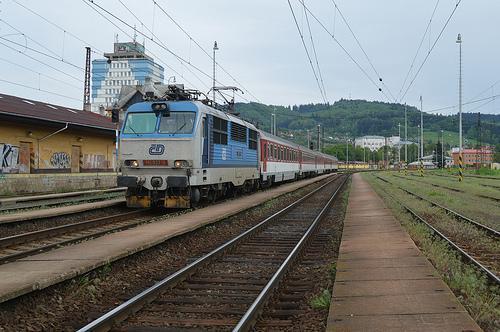How many trains are in the photo?
Give a very brief answer. 1. 